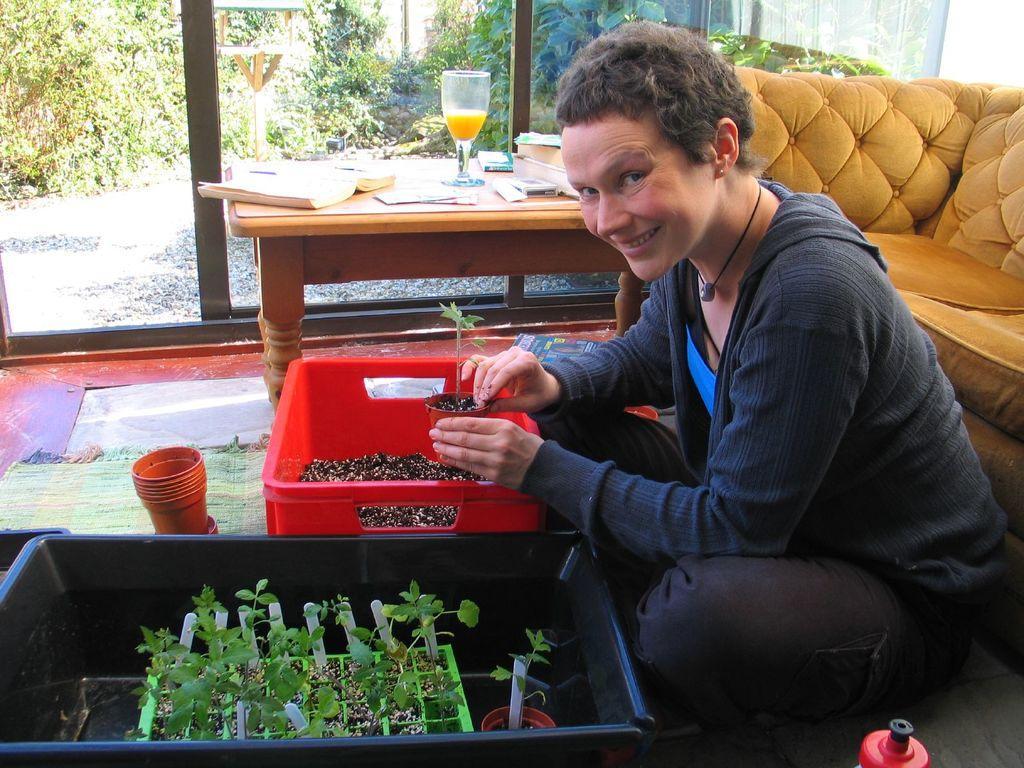Can you describe this image briefly? In this image, we can see a woman is sitting on the floor and holding a pot with plant. Here we can see baskets, plants, few objects, floor with floor mat. Background we can see a couch, table. Few things are placed on the table. Here we can see glass doors. Through the glass we can see the outside view. Here there are so many trees we can see. 